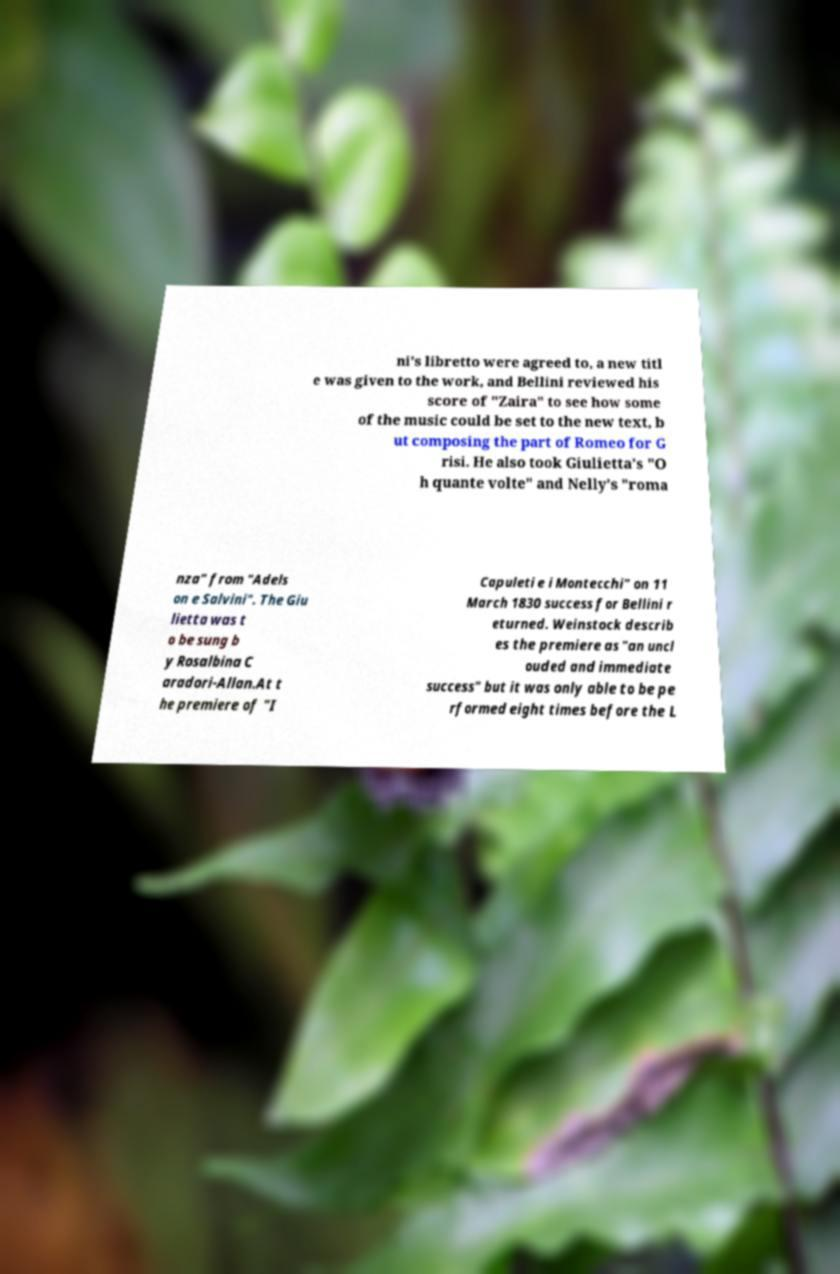Please read and relay the text visible in this image. What does it say? ni's libretto were agreed to, a new titl e was given to the work, and Bellini reviewed his score of "Zaira" to see how some of the music could be set to the new text, b ut composing the part of Romeo for G risi. He also took Giulietta’s "O h quante volte" and Nelly’s "roma nza" from "Adels on e Salvini". The Giu lietta was t o be sung b y Rosalbina C aradori-Allan.At t he premiere of "I Capuleti e i Montecchi" on 11 March 1830 success for Bellini r eturned. Weinstock describ es the premiere as "an uncl ouded and immediate success" but it was only able to be pe rformed eight times before the L 